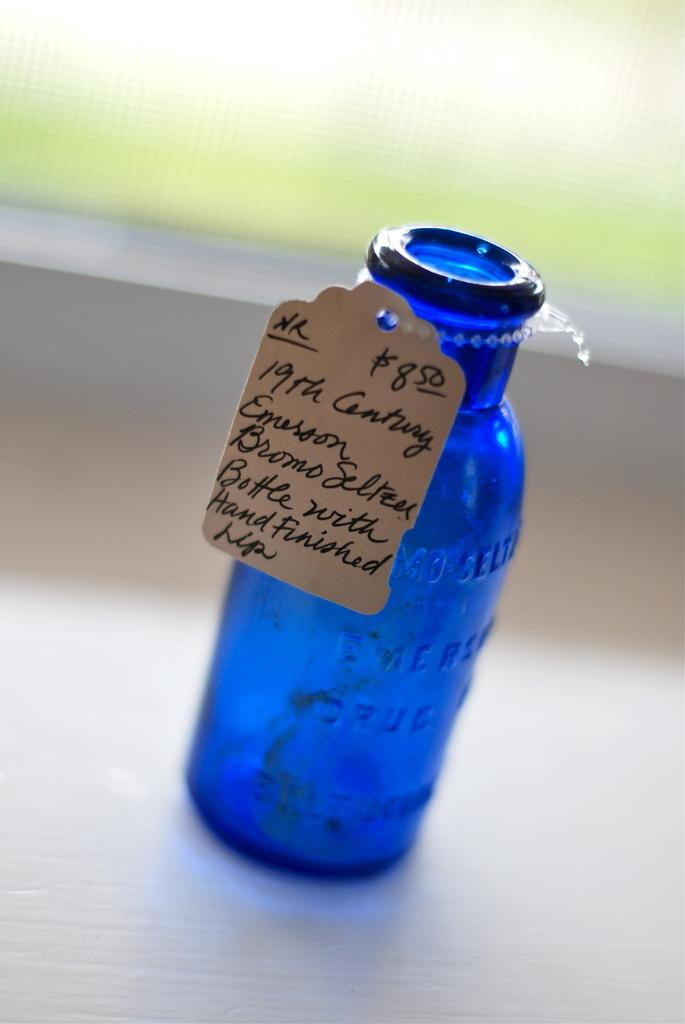<image>
Render a clear and concise summary of the photo. A blue antique Bromo Seltzer bottle is priced at $8.50. 